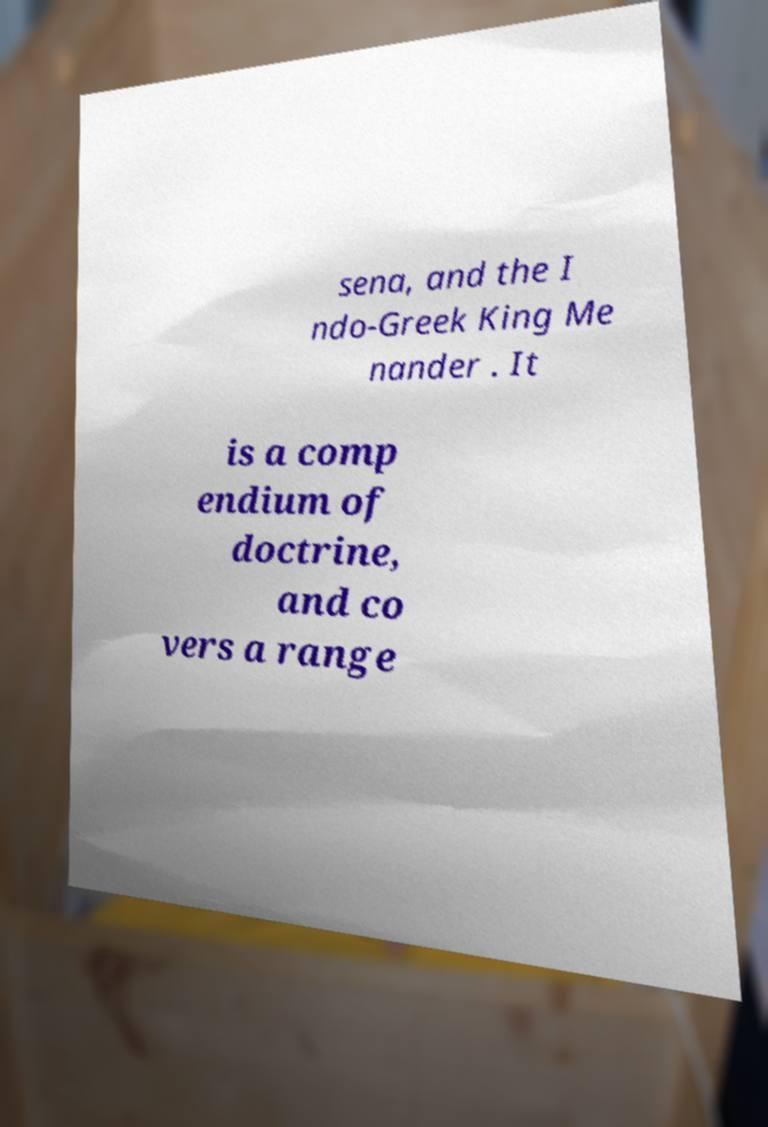What messages or text are displayed in this image? I need them in a readable, typed format. sena, and the I ndo-Greek King Me nander . It is a comp endium of doctrine, and co vers a range 